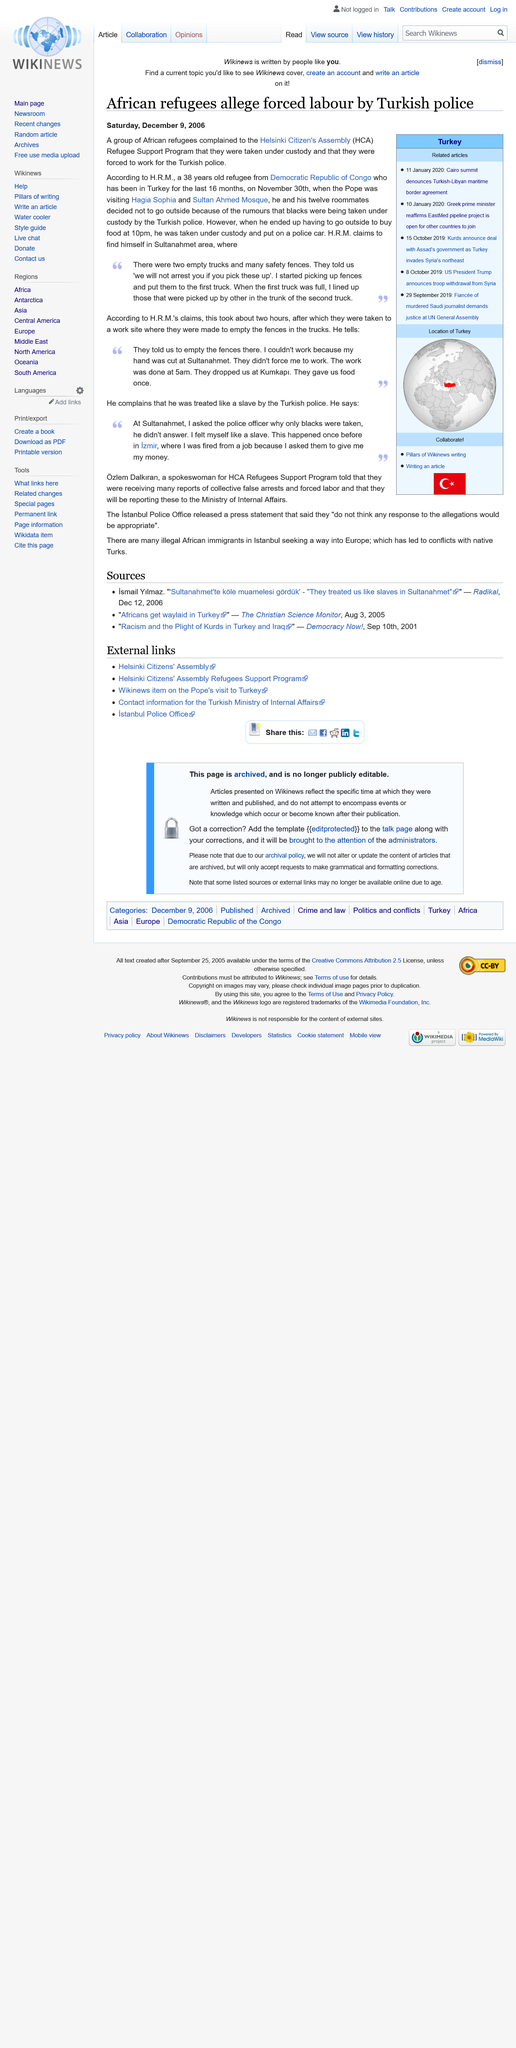Highlight a few significant elements in this photo. On October 15, 2019, the Kurds announced a deal with the Assad government. The article "African refugee alleges forced labor by Turkish police" was published on Saturday, December 9, 2006. 